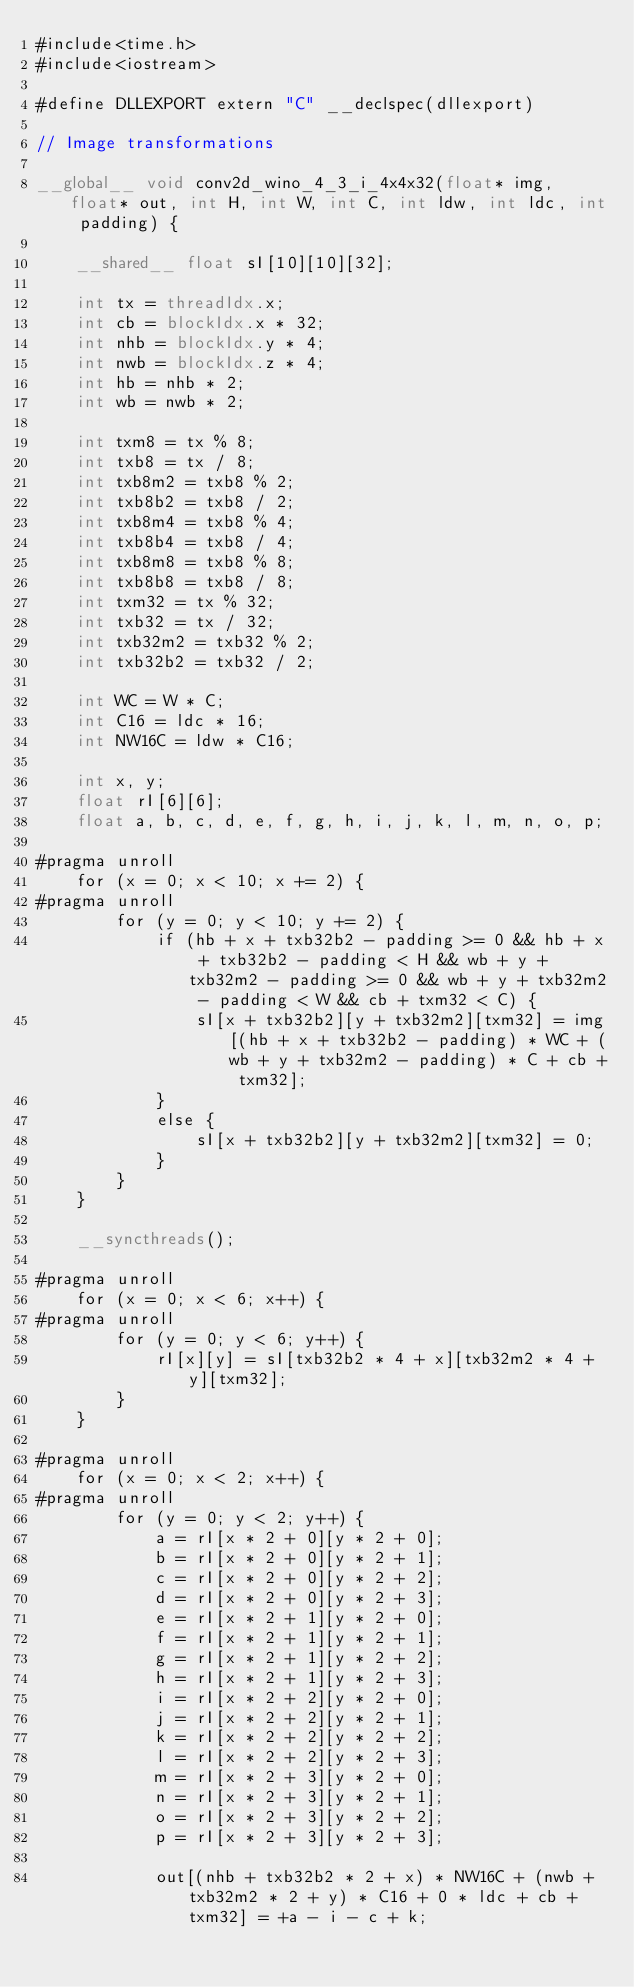<code> <loc_0><loc_0><loc_500><loc_500><_Cuda_>#include<time.h>
#include<iostream>

#define DLLEXPORT extern "C" __declspec(dllexport)

// Image transformations

__global__ void conv2d_wino_4_3_i_4x4x32(float* img, float* out, int H, int W, int C, int ldw, int ldc, int padding) {

    __shared__ float sI[10][10][32];

    int tx = threadIdx.x;
    int cb = blockIdx.x * 32;
    int nhb = blockIdx.y * 4;
    int nwb = blockIdx.z * 4;
    int hb = nhb * 2;
    int wb = nwb * 2;

    int txm8 = tx % 8;
    int txb8 = tx / 8;
    int txb8m2 = txb8 % 2;
    int txb8b2 = txb8 / 2;
    int txb8m4 = txb8 % 4;
    int txb8b4 = txb8 / 4;
    int txb8m8 = txb8 % 8;
    int txb8b8 = txb8 / 8;
    int txm32 = tx % 32;
    int txb32 = tx / 32;
    int txb32m2 = txb32 % 2;
    int txb32b2 = txb32 / 2;

    int WC = W * C;
    int C16 = ldc * 16;
    int NW16C = ldw * C16;

    int x, y;
    float rI[6][6];
    float a, b, c, d, e, f, g, h, i, j, k, l, m, n, o, p;

#pragma unroll
    for (x = 0; x < 10; x += 2) {
#pragma unroll
        for (y = 0; y < 10; y += 2) {
            if (hb + x + txb32b2 - padding >= 0 && hb + x + txb32b2 - padding < H && wb + y + txb32m2 - padding >= 0 && wb + y + txb32m2 - padding < W && cb + txm32 < C) {
                sI[x + txb32b2][y + txb32m2][txm32] = img[(hb + x + txb32b2 - padding) * WC + (wb + y + txb32m2 - padding) * C + cb + txm32];
            }
            else {
                sI[x + txb32b2][y + txb32m2][txm32] = 0;
            }
        }
    }

    __syncthreads();

#pragma unroll
    for (x = 0; x < 6; x++) {
#pragma unroll
        for (y = 0; y < 6; y++) {
            rI[x][y] = sI[txb32b2 * 4 + x][txb32m2 * 4 + y][txm32];
        }
    }

#pragma unroll
    for (x = 0; x < 2; x++) {
#pragma unroll
        for (y = 0; y < 2; y++) {
            a = rI[x * 2 + 0][y * 2 + 0];
            b = rI[x * 2 + 0][y * 2 + 1];
            c = rI[x * 2 + 0][y * 2 + 2];
            d = rI[x * 2 + 0][y * 2 + 3];
            e = rI[x * 2 + 1][y * 2 + 0];
            f = rI[x * 2 + 1][y * 2 + 1];
            g = rI[x * 2 + 1][y * 2 + 2];
            h = rI[x * 2 + 1][y * 2 + 3];
            i = rI[x * 2 + 2][y * 2 + 0];
            j = rI[x * 2 + 2][y * 2 + 1];
            k = rI[x * 2 + 2][y * 2 + 2];
            l = rI[x * 2 + 2][y * 2 + 3];
            m = rI[x * 2 + 3][y * 2 + 0];
            n = rI[x * 2 + 3][y * 2 + 1];
            o = rI[x * 2 + 3][y * 2 + 2];
            p = rI[x * 2 + 3][y * 2 + 3];

            out[(nhb + txb32b2 * 2 + x) * NW16C + (nwb + txb32m2 * 2 + y) * C16 + 0 * ldc + cb + txm32] = +a - i - c + k;</code> 